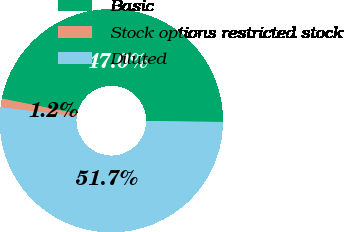Convert chart to OTSL. <chart><loc_0><loc_0><loc_500><loc_500><pie_chart><fcel>Basic<fcel>Stock options restricted stock<fcel>Diluted<nl><fcel>47.02%<fcel>1.25%<fcel>51.73%<nl></chart> 